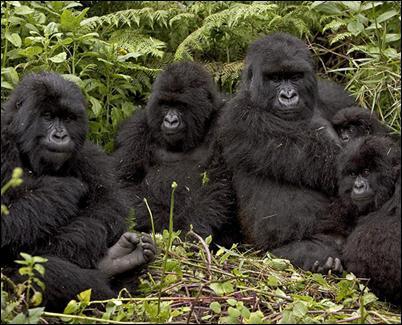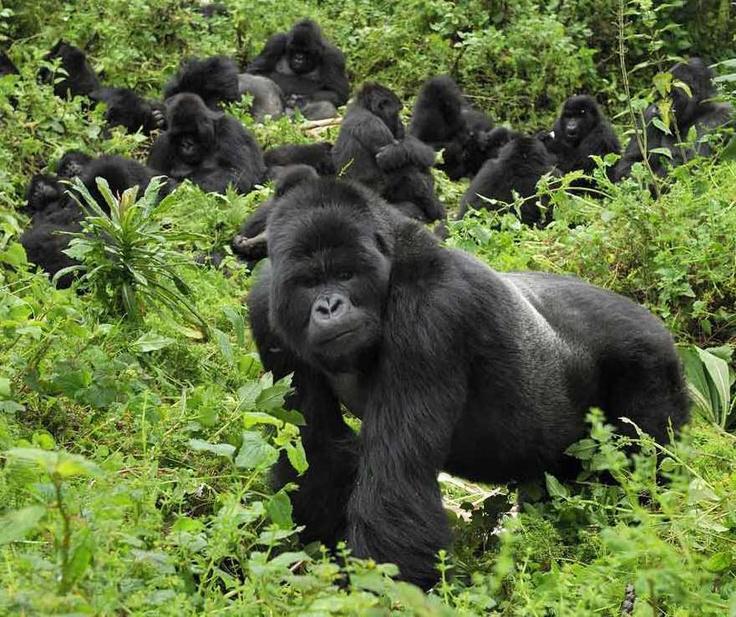The first image is the image on the left, the second image is the image on the right. Given the left and right images, does the statement "Right image shows one foreground family-type gorilla group, which includes young gorillas." hold true? Answer yes or no. No. The first image is the image on the left, the second image is the image on the right. Considering the images on both sides, is "One of the images shows at least one gorilla standing on its hands." valid? Answer yes or no. Yes. 